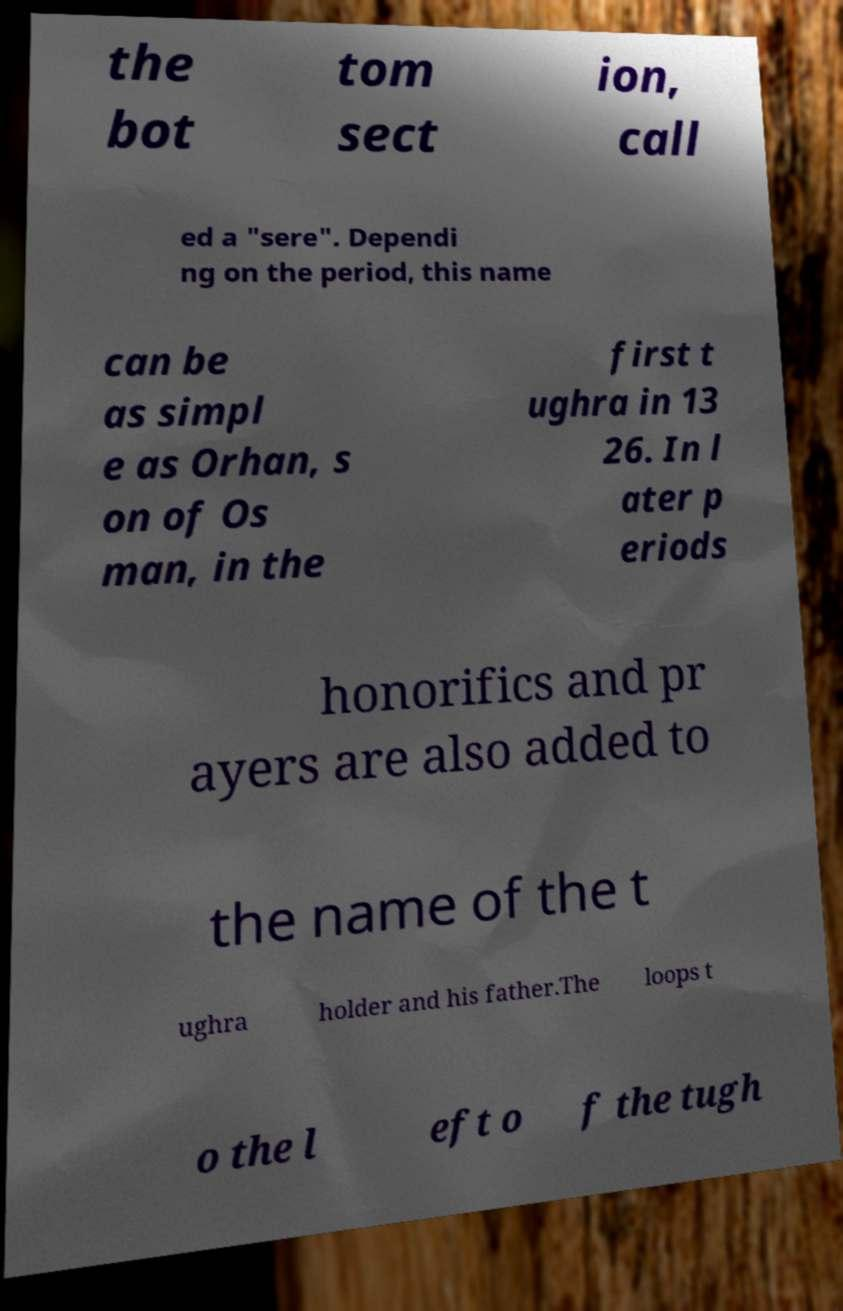Please read and relay the text visible in this image. What does it say? the bot tom sect ion, call ed a "sere". Dependi ng on the period, this name can be as simpl e as Orhan, s on of Os man, in the first t ughra in 13 26. In l ater p eriods honorifics and pr ayers are also added to the name of the t ughra holder and his father.The loops t o the l eft o f the tugh 